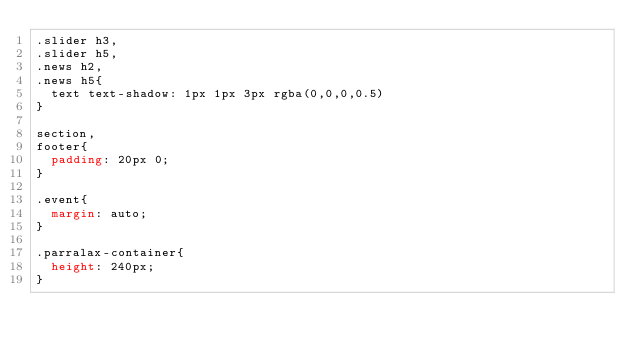<code> <loc_0><loc_0><loc_500><loc_500><_CSS_>.slider h3,
.slider h5,
.news h2,
.news h5{
	text text-shadow: 1px 1px 3px rgba(0,0,0,0.5)  
}

section,
footer{
	padding: 20px 0;
}

.event{
	margin: auto;
}

.parralax-container{
	height: 240px;
}</code> 